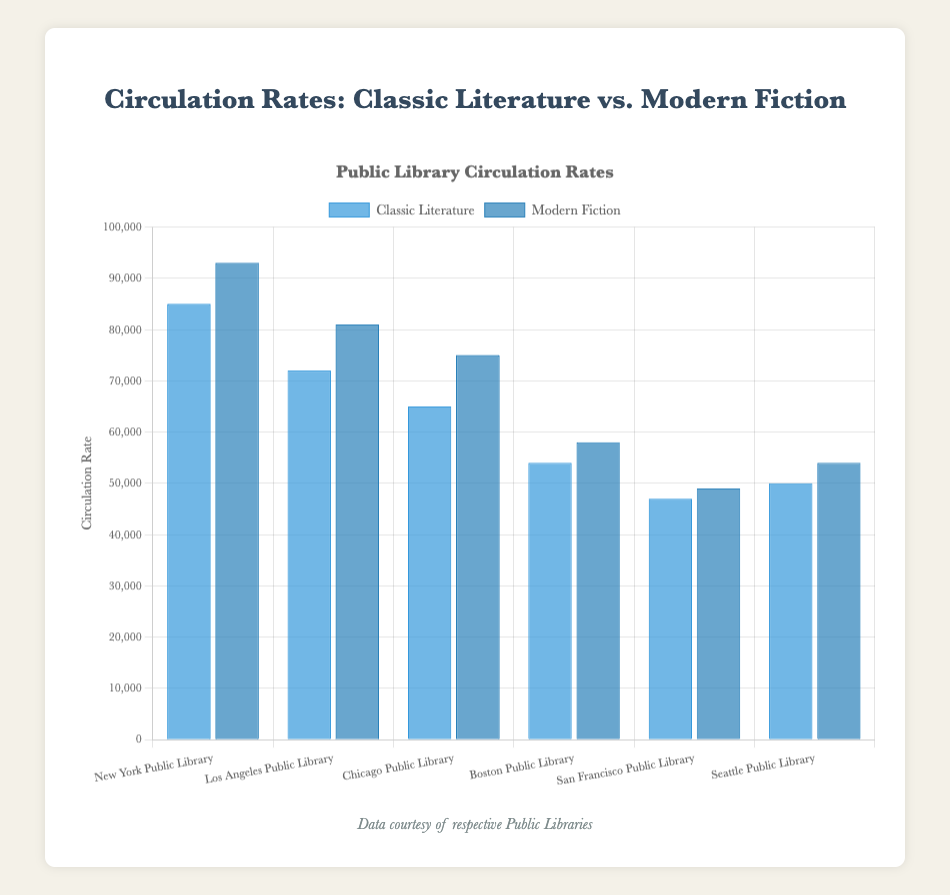Which library has the highest circulation rate for modern fiction? By looking at the height of the bars representing modern fiction, we can see that the New York Public Library has the tallest bar, indicating the highest circulation rate for modern fiction.
Answer: New York Public Library Which library has the lowest circulation rate for classic literature? Observing the heights of the bars representing classic literature, we notice that the San Francisco Public Library has the shortest bar, indicating the lowest circulation rate for classic literature.
Answer: San Francisco Public Library What is the total circulation rate of classic literature across all libraries? Sum the circulation rates of classic literature for each library: 85000 (New York) + 72000 (Los Angeles) + 65000 (Chicago) + 54000 (Boston) + 47000 (San Francisco) + 50000 (Seattle) = 373000.
Answer: 373000 How does the circulation rate of modern fiction compare between the Boston and Seattle public libraries? Compare the heights of the modern fiction bars for Boston (58000) and Seattle (54000). The Boston Public Library has a slightly higher circulation rate for modern fiction.
Answer: Boston Public Library Which category, classic literature or modern fiction, generally has higher circulation rates in the displayed libraries? By comparing the general height of the bars for classic literature and modern fiction across all libraries, modern fiction bars are generally taller than those for classic literature.
Answer: Modern Fiction What is the average circulation rate of modern fiction in the six libraries? Sum the modern fiction rates and divide by the number of libraries: (93000 + 81000 + 75000 + 58000 + 49000 + 54000) / 6 = 510000 / 6 ≈ 85000.
Answer: 85000 What is the difference in circulation rates for classic literature and modern fiction in the Chicago Public Library? Subtract the circulation rate for classic literature from that of modern fiction in Chicago: 75000 - 65000 = 10000.
Answer: 10000 Which library has a greater difference between classic literature and modern fiction circulation rates? Calculate the difference for each library and compare: 
New York (93000 - 85000 = 8000),
Los Angeles (81000 - 72000 = 9000),
Chicago (75000 - 65000 = 10000),
Boston (58000 - 54000 = 4000),
San Francisco (49000 - 47000 = 2000),
Seattle (54000 - 50000 = 4000).
The Chicago Public Library has the greatest difference of 10000.
Answer: Chicago Public Library Are the circulation rates for classic literature and modern fiction in the Los Angeles Public Library higher or lower than in the New York Public Library? The modern fiction circulation rates in New York (93000) and Los Angeles (81000), and the classic literature rates in New York (85000) and Los Angeles (72000), indicate that both classic literature and modern fiction rates in Los Angeles are lower than those in New York.
Answer: Lower 